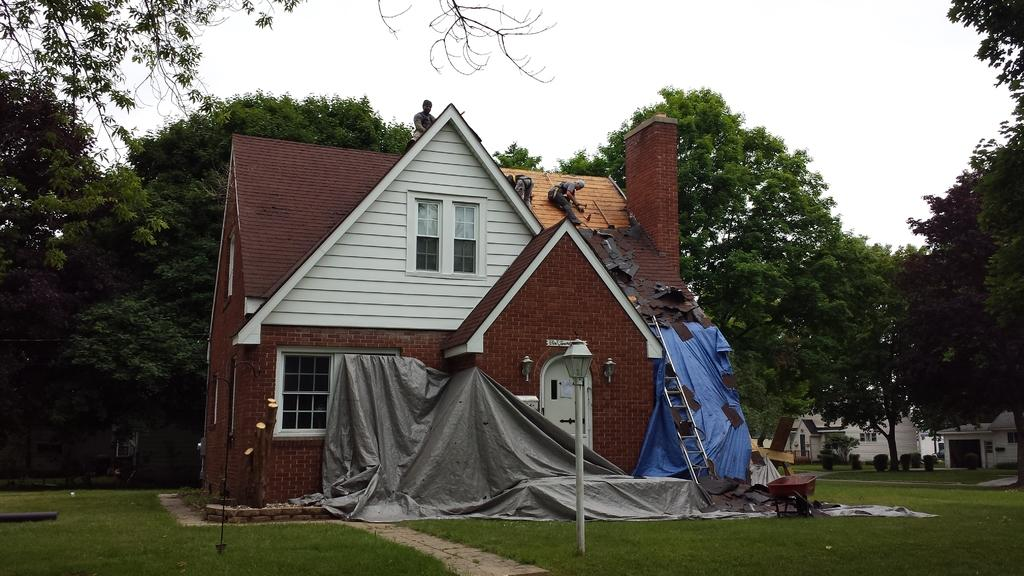What type of structure is present in the image? There is a house in the image. What activity is taking place at the house? The house is being repaired by people. What can be seen in the background of the image? There are trees visible in the image. What type of sail can be seen on the house in the image? There is no sail present on the house in the image. Is it raining in the image? The provided facts do not mention any rain in the image. 